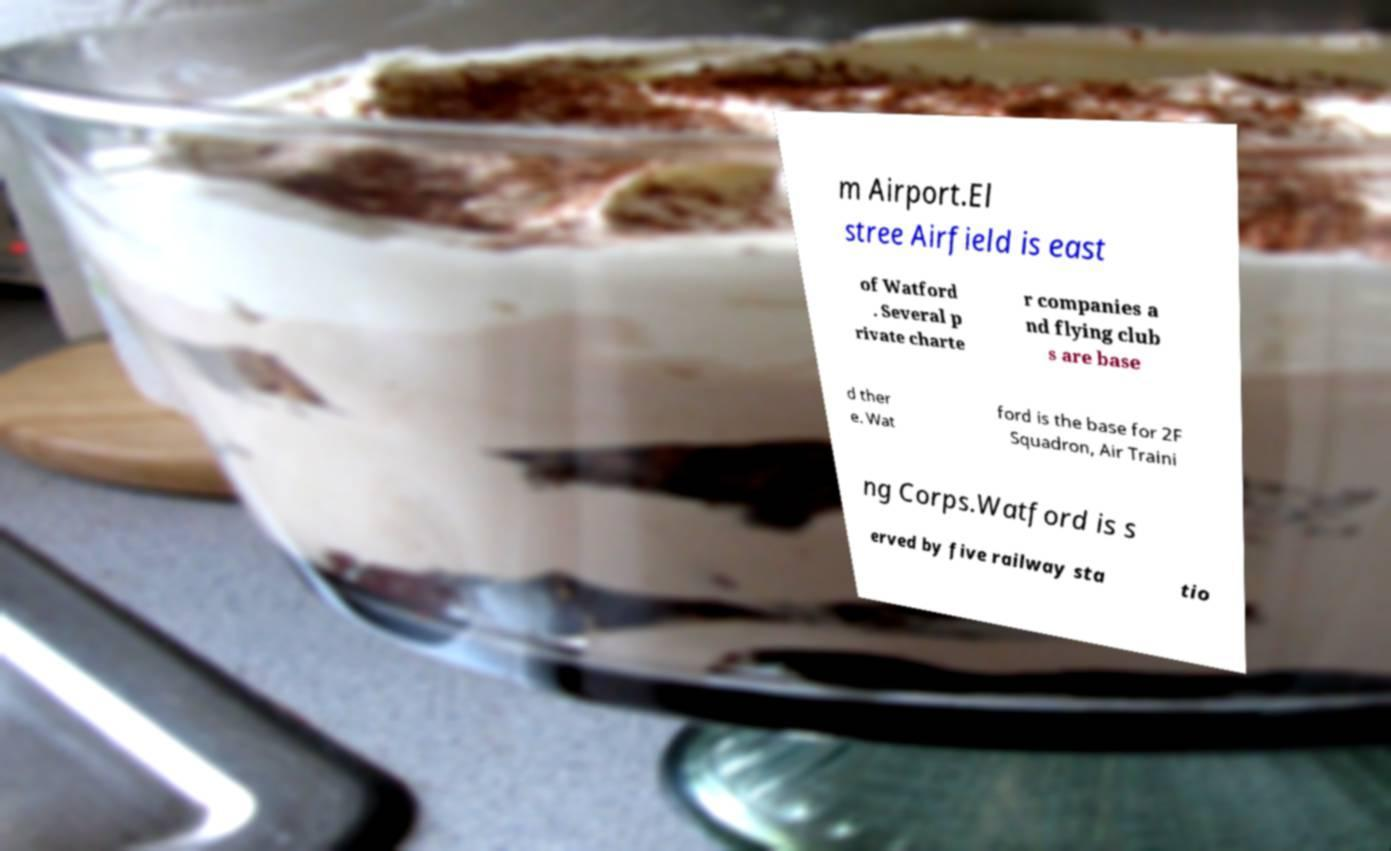For documentation purposes, I need the text within this image transcribed. Could you provide that? m Airport.El stree Airfield is east of Watford . Several p rivate charte r companies a nd flying club s are base d ther e. Wat ford is the base for 2F Squadron, Air Traini ng Corps.Watford is s erved by five railway sta tio 